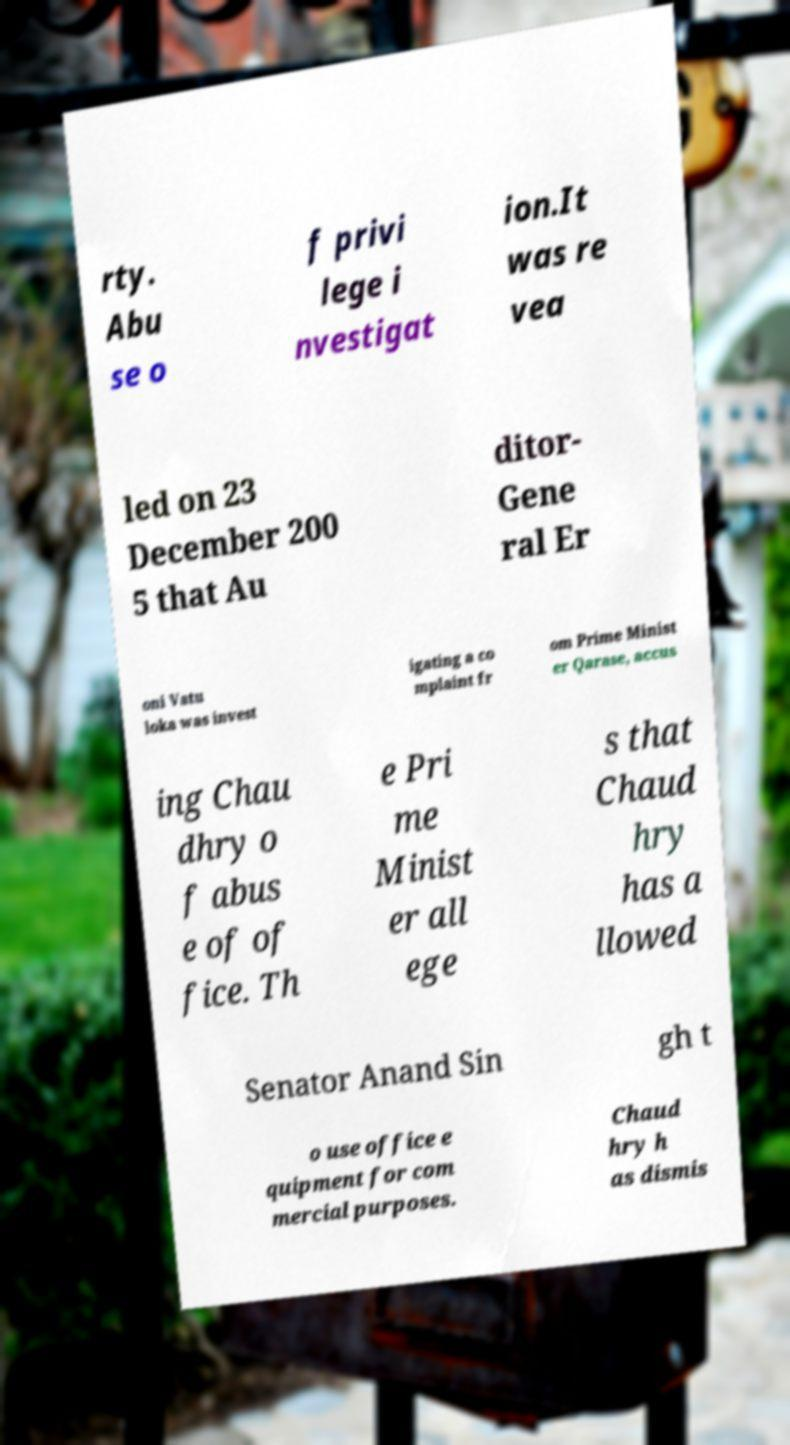For documentation purposes, I need the text within this image transcribed. Could you provide that? rty. Abu se o f privi lege i nvestigat ion.It was re vea led on 23 December 200 5 that Au ditor- Gene ral Er oni Vatu loka was invest igating a co mplaint fr om Prime Minist er Qarase, accus ing Chau dhry o f abus e of of fice. Th e Pri me Minist er all ege s that Chaud hry has a llowed Senator Anand Sin gh t o use office e quipment for com mercial purposes. Chaud hry h as dismis 